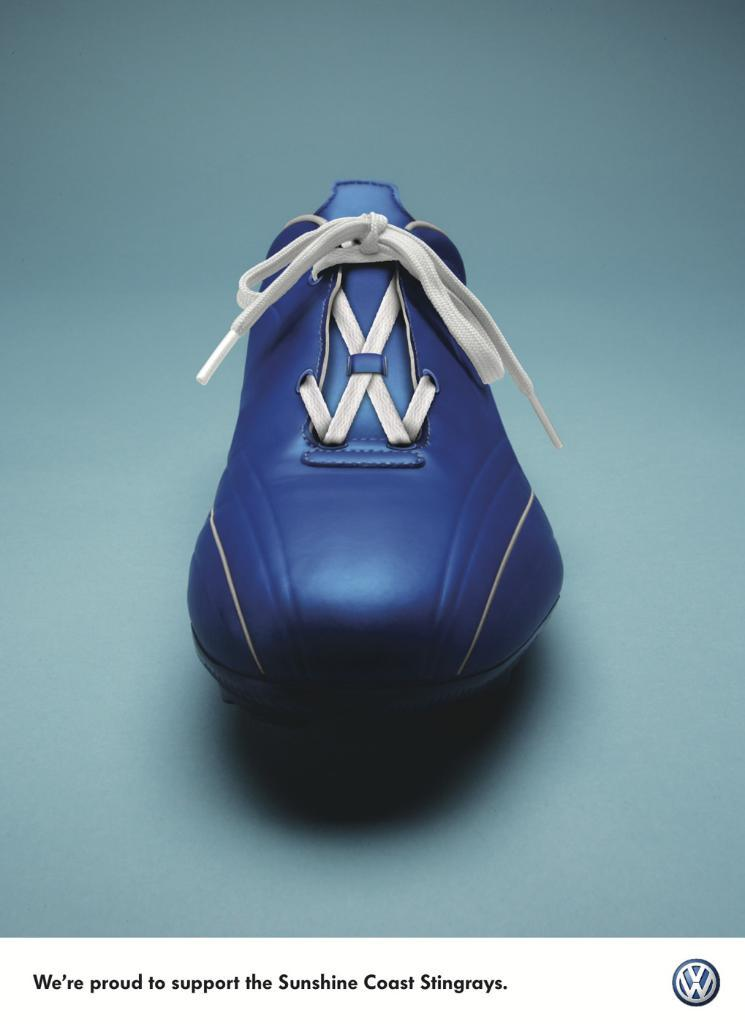<image>
Summarize the visual content of the image. Blue shoe presented by Volkswagon and says: We're proud to support the Sunshine Coast Stingrays. 